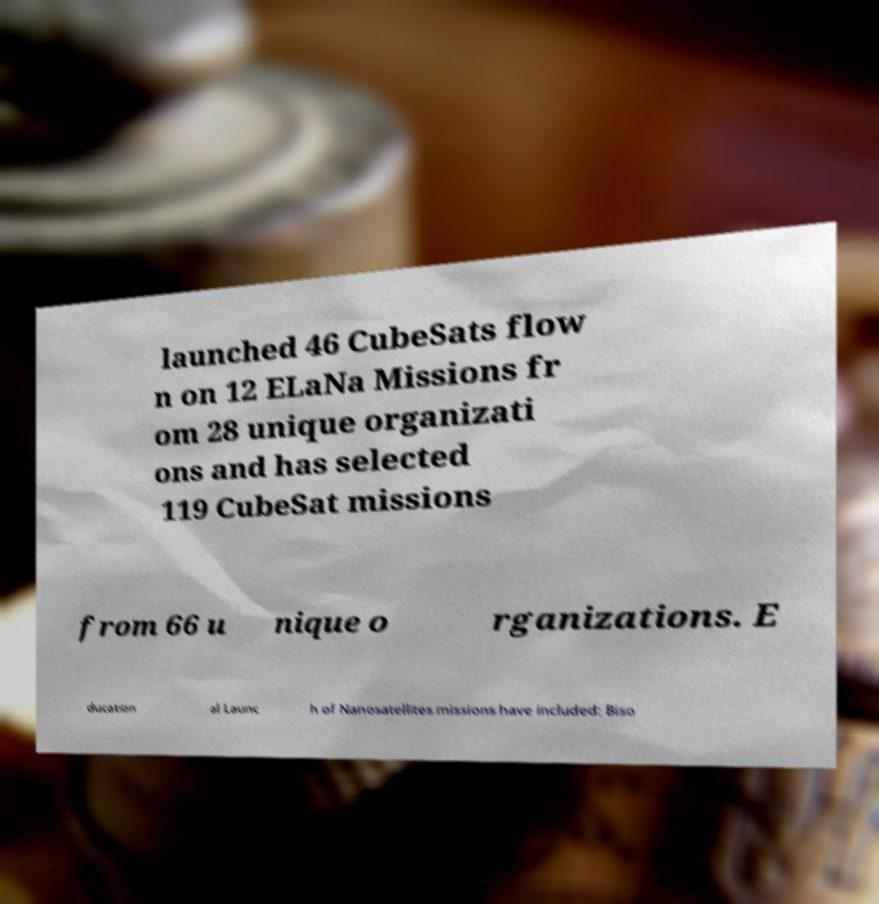For documentation purposes, I need the text within this image transcribed. Could you provide that? launched 46 CubeSats flow n on 12 ELaNa Missions fr om 28 unique organizati ons and has selected 119 CubeSat missions from 66 u nique o rganizations. E ducation al Launc h of Nanosatellites missions have included: Biso 